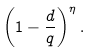<formula> <loc_0><loc_0><loc_500><loc_500>\left ( 1 - \frac { d } { q } \right ) ^ { \eta } .</formula> 